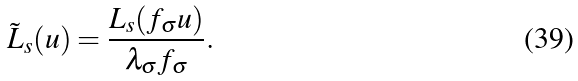Convert formula to latex. <formula><loc_0><loc_0><loc_500><loc_500>\tilde { L } _ { s } ( u ) = \frac { L _ { s } ( f _ { \sigma } u ) } { \lambda _ { \sigma } f _ { \sigma } } .</formula> 